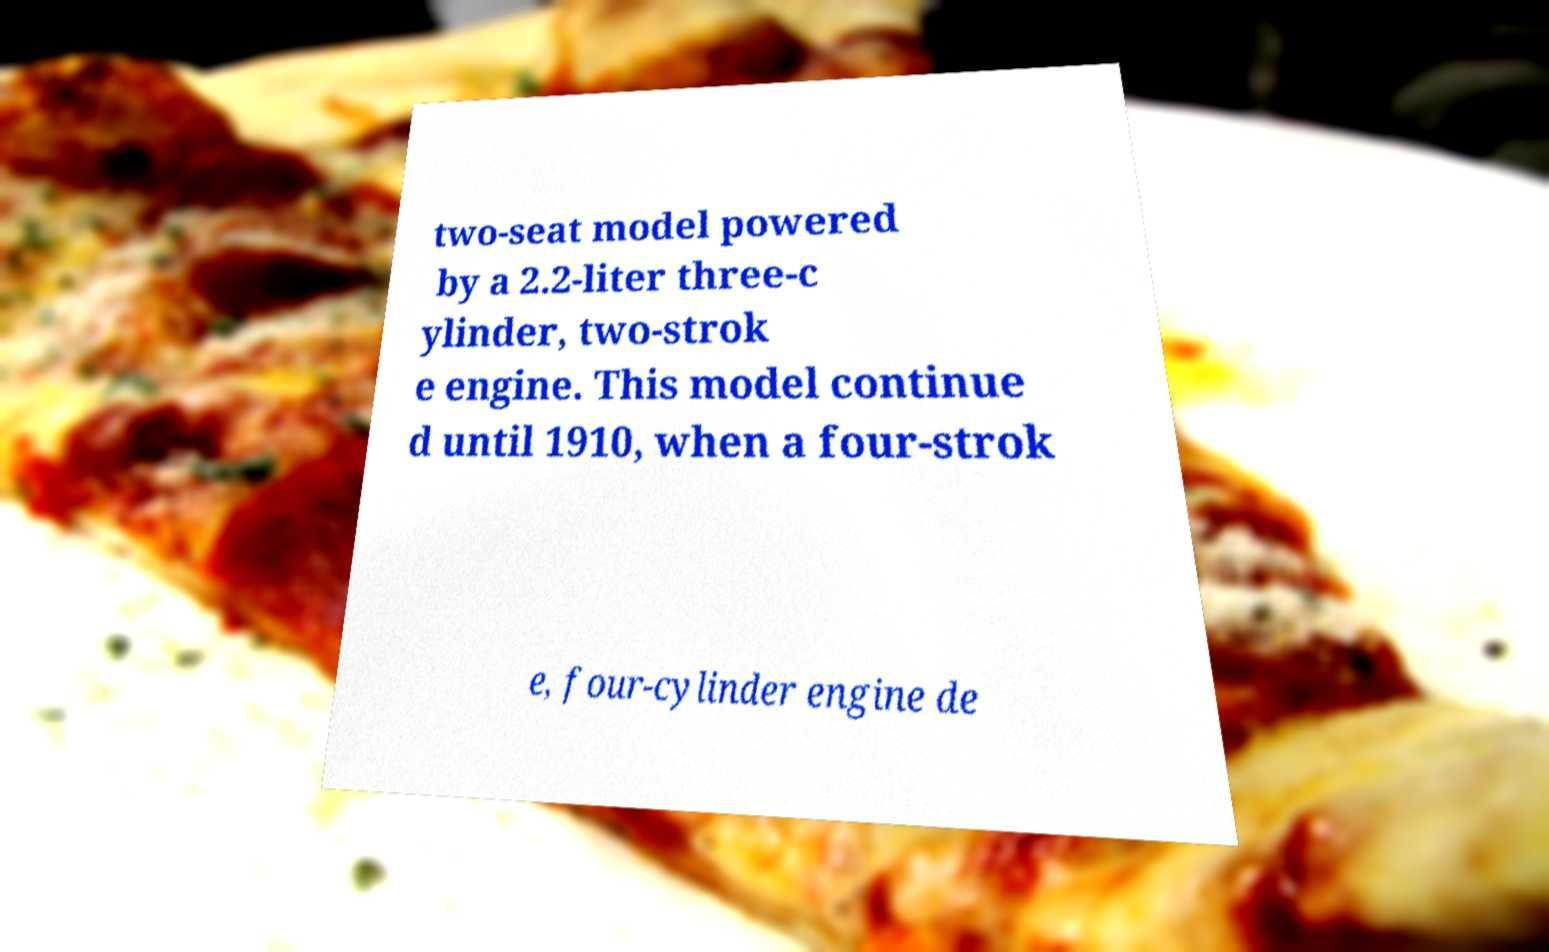I need the written content from this picture converted into text. Can you do that? two-seat model powered by a 2.2-liter three-c ylinder, two-strok e engine. This model continue d until 1910, when a four-strok e, four-cylinder engine de 